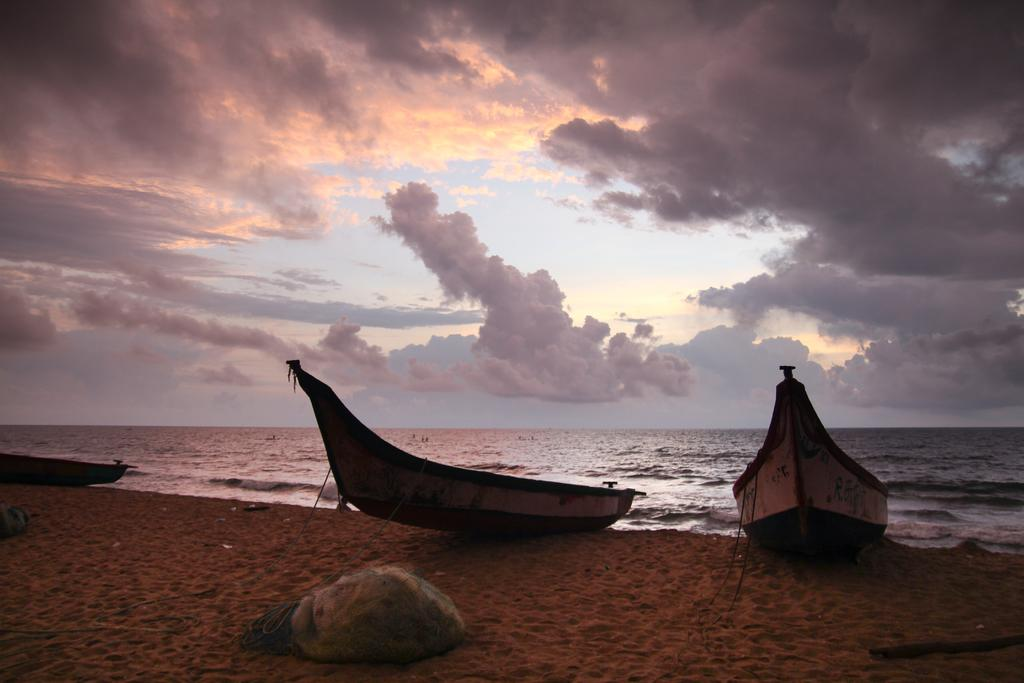What type of vehicles are on the sand in the image? There are boats on the sand in the image. What can be seen behind the boats? There is a sea visible behind the boats. What is blocking the view of the boats in the image? There is an object in front of the boats. What is visible in the sky at the top of the image? Clouds are present in the sky at the top of the image. Can you see any trees involved in an argument in the image? There are no trees or arguments present in the image. 